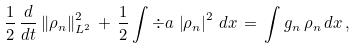<formula> <loc_0><loc_0><loc_500><loc_500>\frac { 1 } { 2 } \, \frac { d } { d t } \left \| \rho _ { n } \right \| ^ { 2 } _ { L ^ { 2 } } \, + \, \frac { 1 } { 2 } \int \div a \, \left | \rho _ { n } \right | ^ { 2 } \, d x \, = \, \int g _ { n } \, \rho _ { n } \, d x \, ,</formula> 